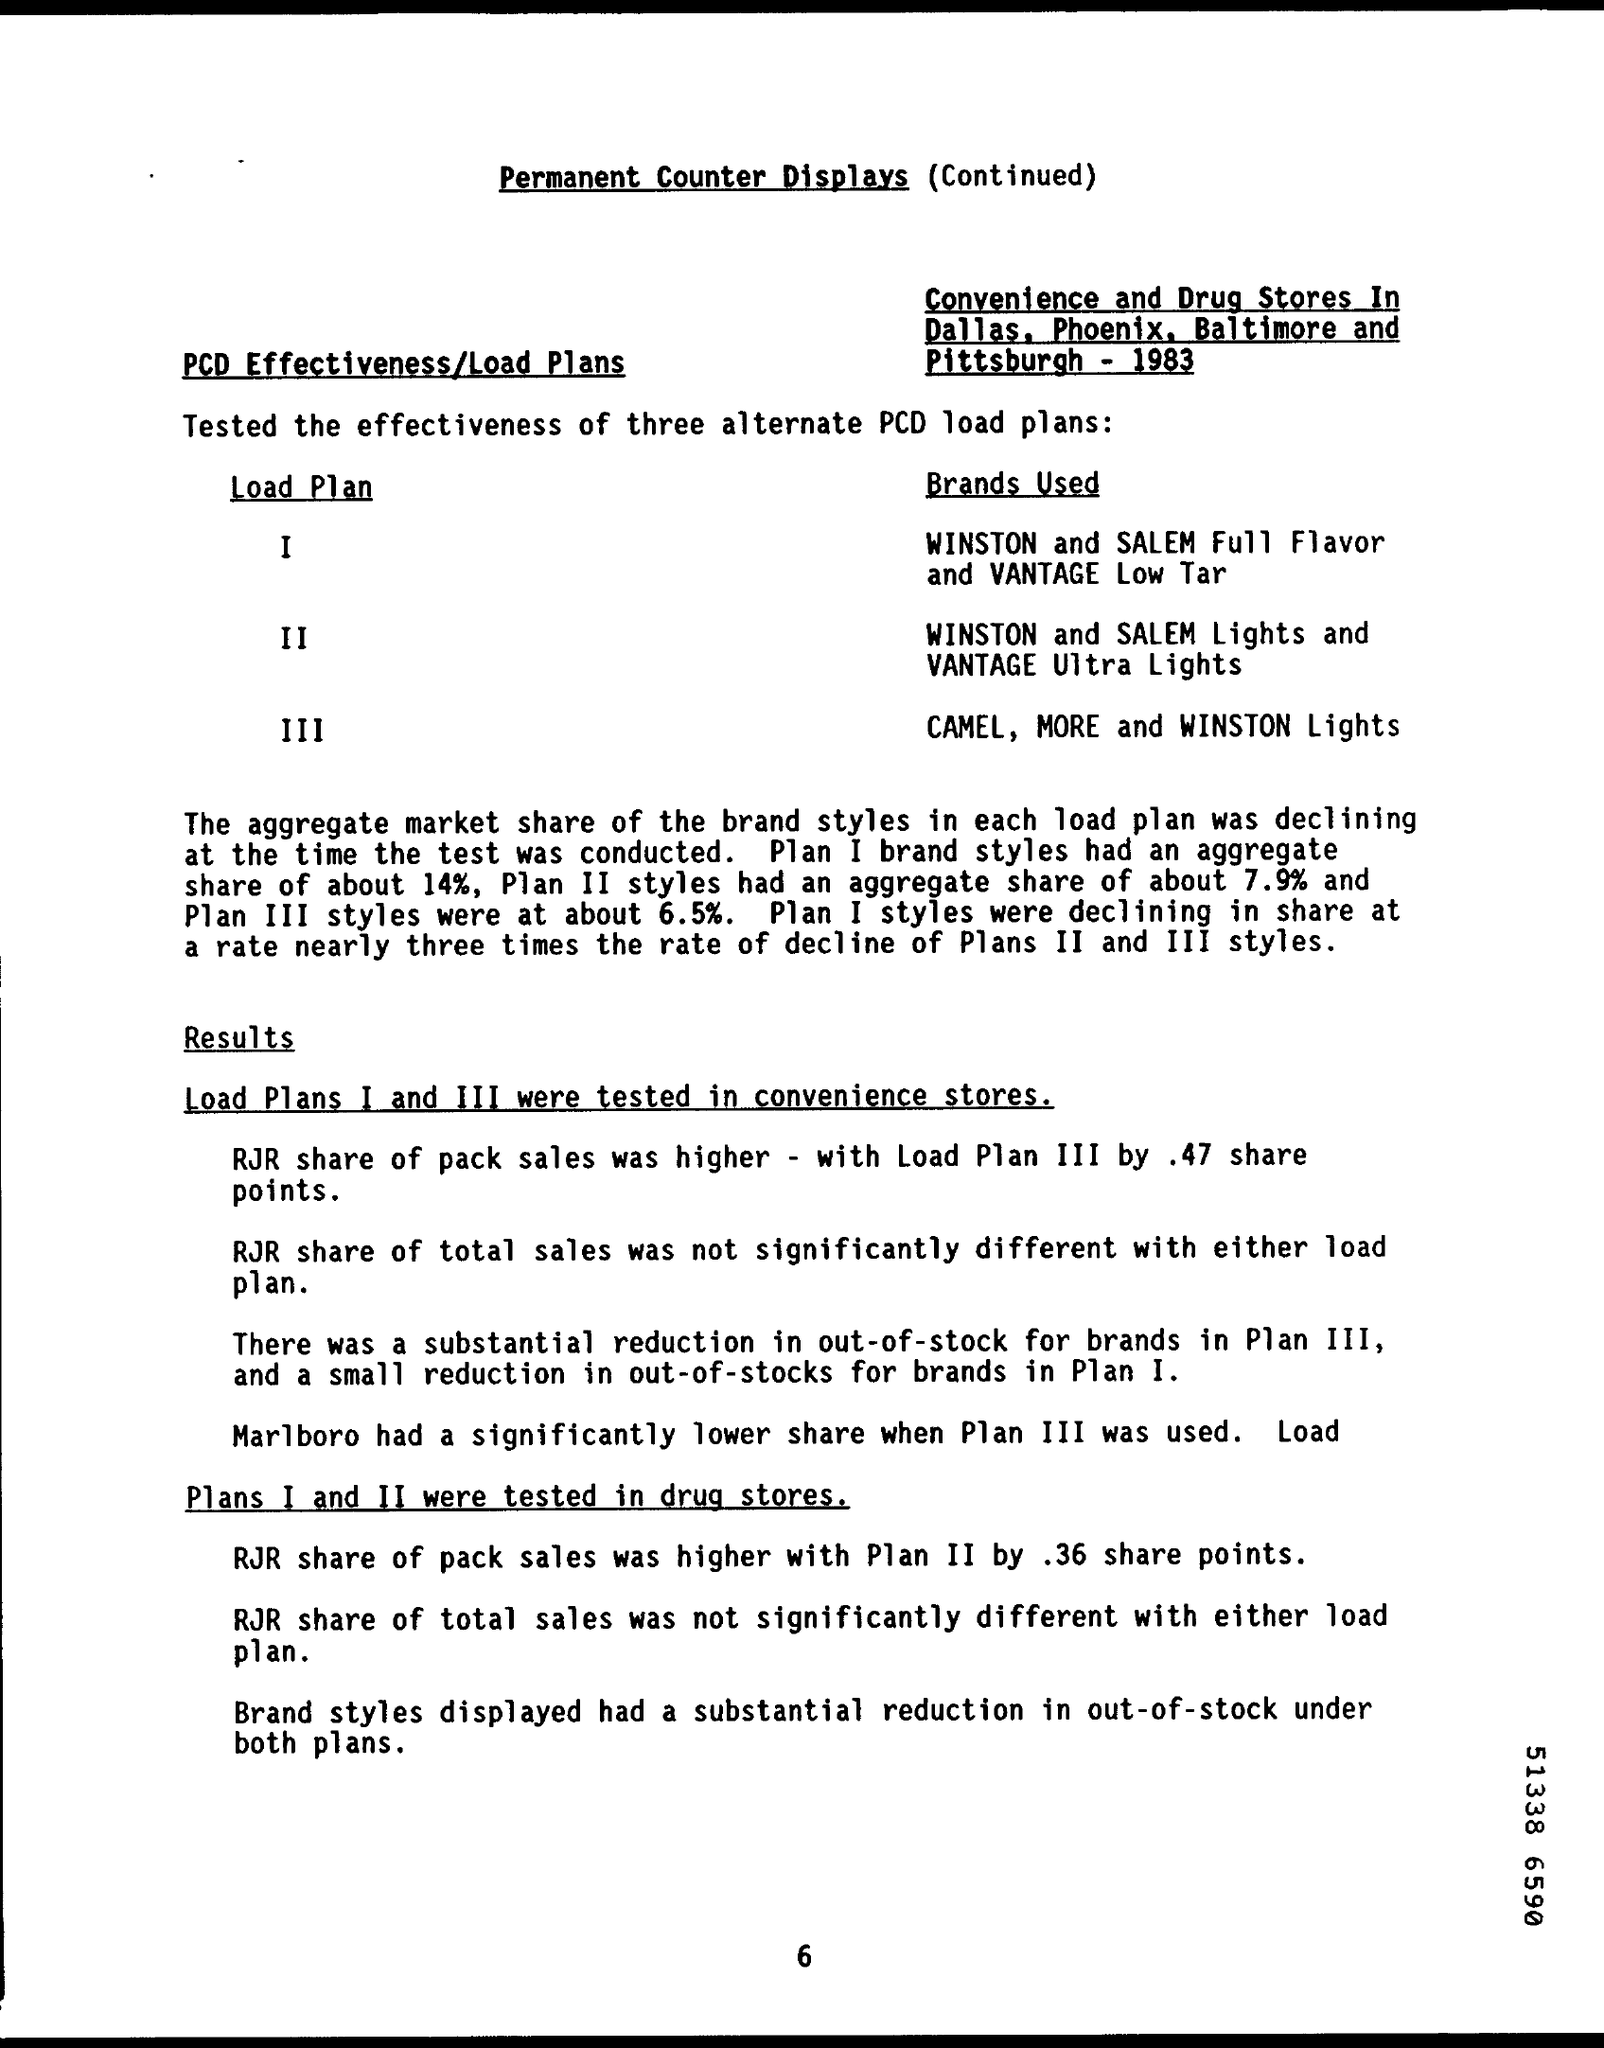Point out several critical features in this image. The title of the document is 'Permanent Counter Displays'. According to our records, approximately 6.5% of Plan III brand styles have been aggregated. The Plan I brand styles' aggregate share is 14%. The aggregate share of Plan II brand styles is 7.9%. 